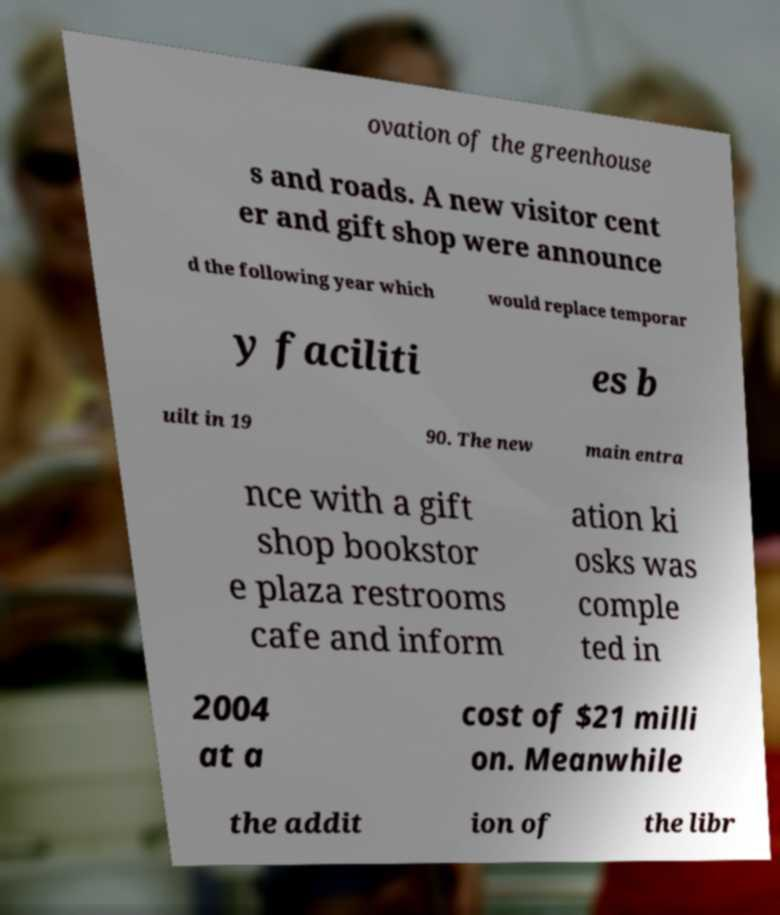Can you read and provide the text displayed in the image?This photo seems to have some interesting text. Can you extract and type it out for me? ovation of the greenhouse s and roads. A new visitor cent er and gift shop were announce d the following year which would replace temporar y faciliti es b uilt in 19 90. The new main entra nce with a gift shop bookstor e plaza restrooms cafe and inform ation ki osks was comple ted in 2004 at a cost of $21 milli on. Meanwhile the addit ion of the libr 